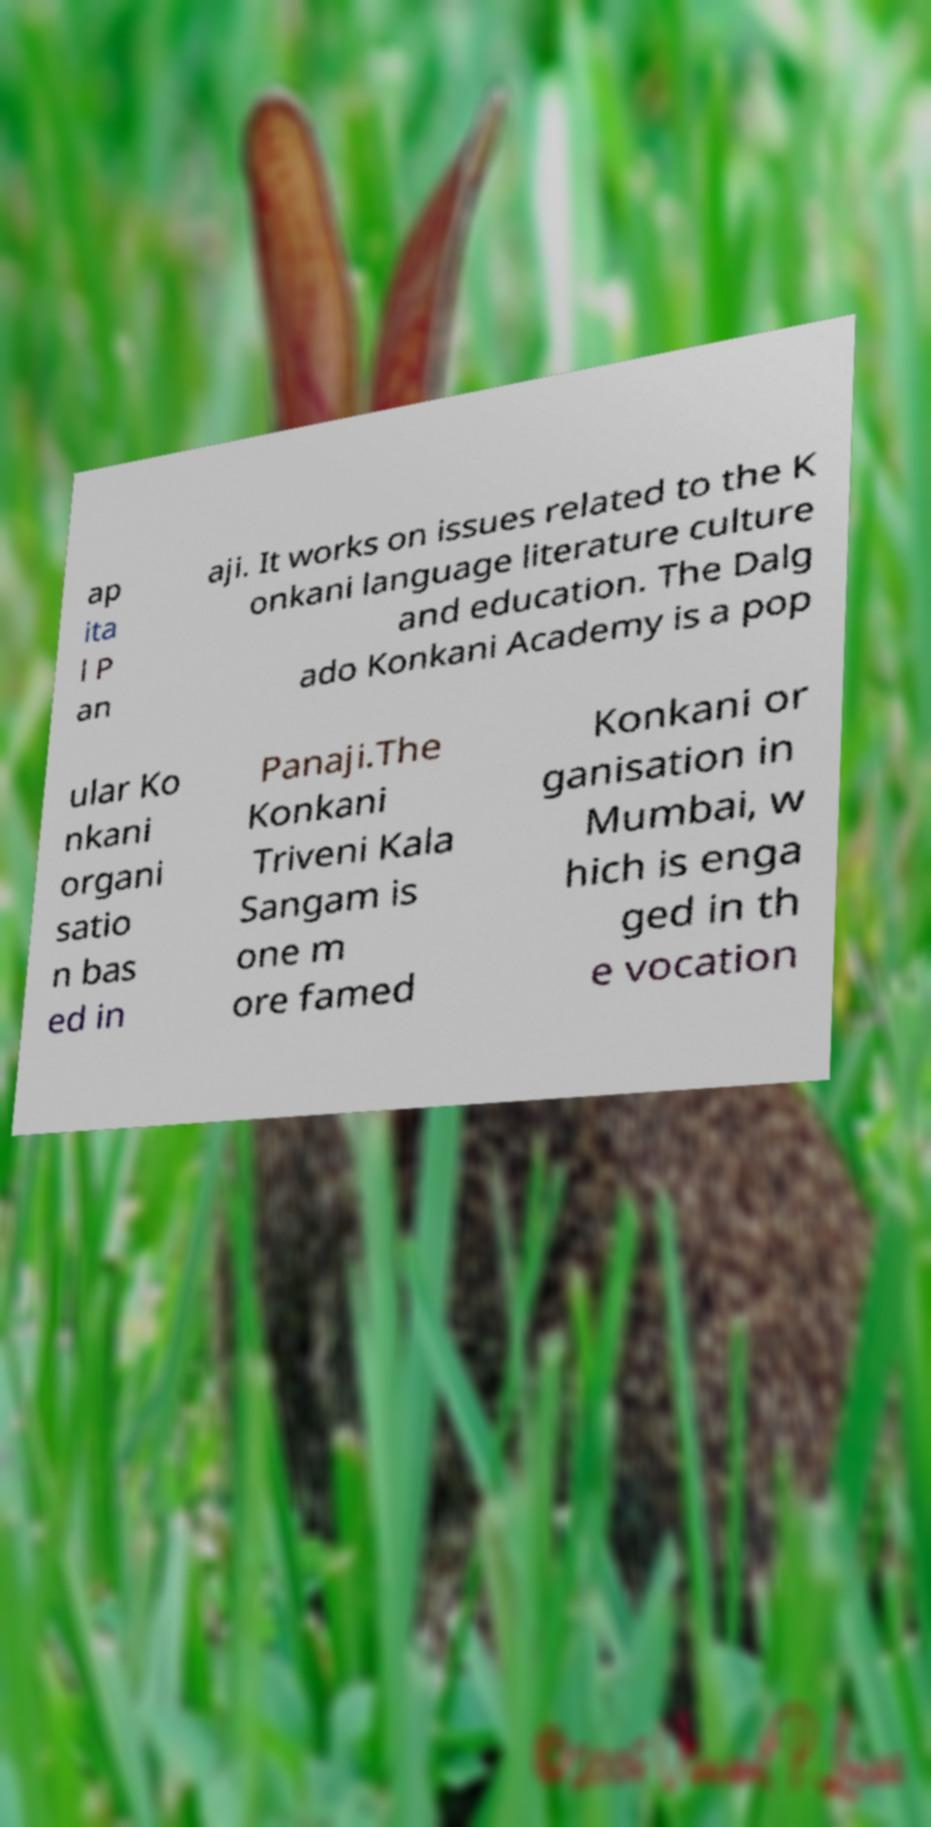Can you read and provide the text displayed in the image?This photo seems to have some interesting text. Can you extract and type it out for me? ap ita l P an aji. It works on issues related to the K onkani language literature culture and education. The Dalg ado Konkani Academy is a pop ular Ko nkani organi satio n bas ed in Panaji.The Konkani Triveni Kala Sangam is one m ore famed Konkani or ganisation in Mumbai, w hich is enga ged in th e vocation 